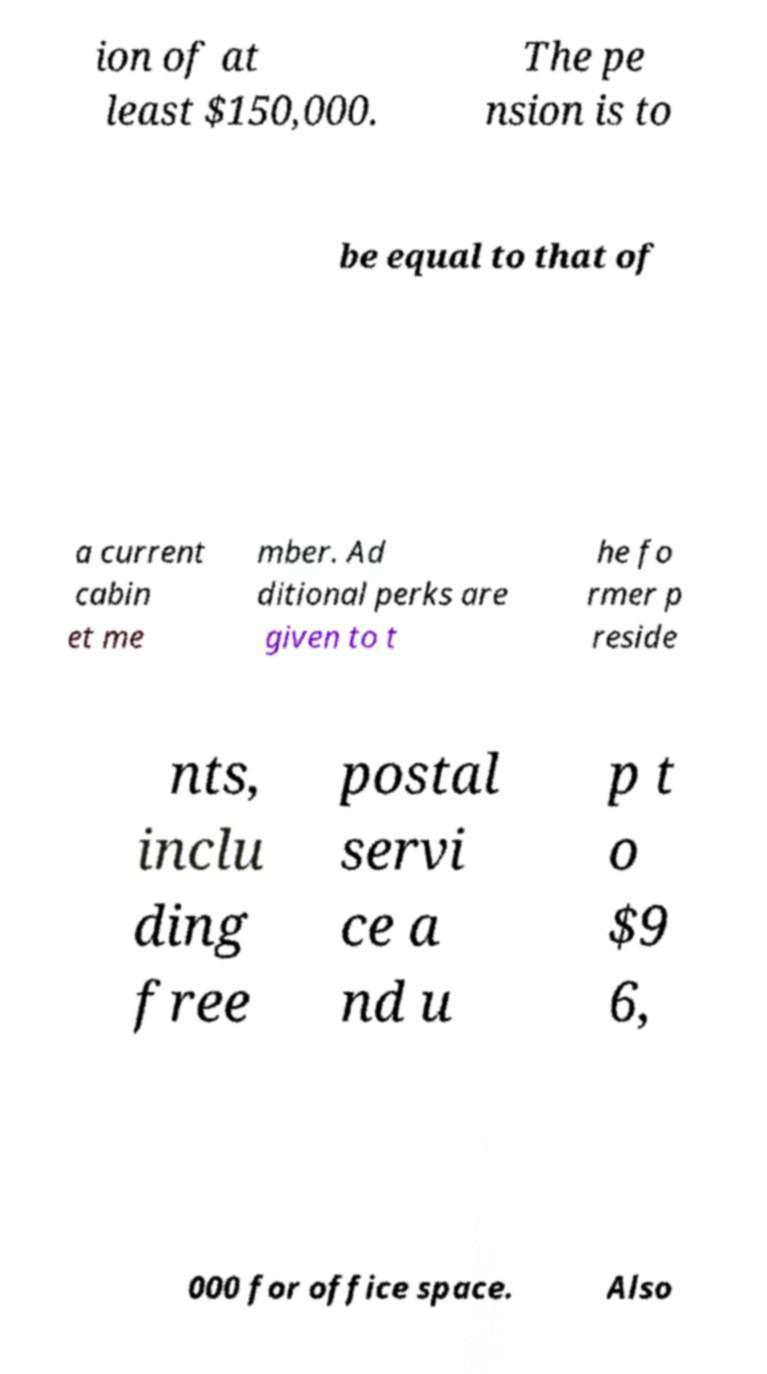For documentation purposes, I need the text within this image transcribed. Could you provide that? ion of at least $150,000. The pe nsion is to be equal to that of a current cabin et me mber. Ad ditional perks are given to t he fo rmer p reside nts, inclu ding free postal servi ce a nd u p t o $9 6, 000 for office space. Also 